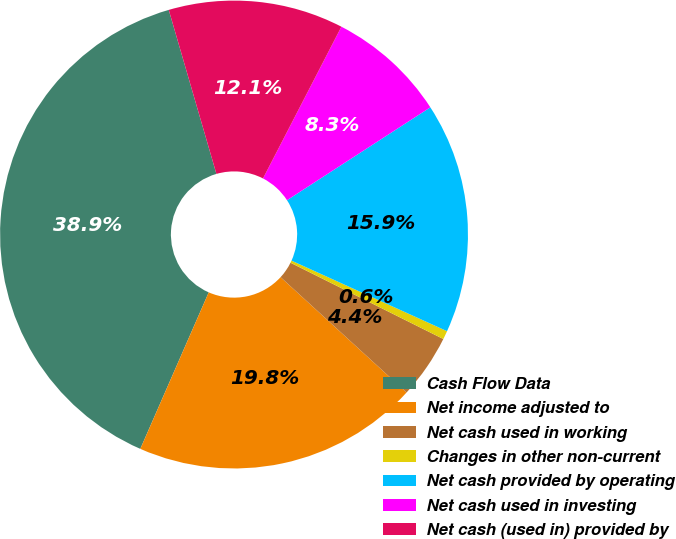Convert chart to OTSL. <chart><loc_0><loc_0><loc_500><loc_500><pie_chart><fcel>Cash Flow Data<fcel>Net income adjusted to<fcel>Net cash used in working<fcel>Changes in other non-current<fcel>Net cash provided by operating<fcel>Net cash used in investing<fcel>Net cash (used in) provided by<nl><fcel>38.94%<fcel>19.76%<fcel>4.43%<fcel>0.59%<fcel>15.93%<fcel>8.26%<fcel>12.09%<nl></chart> 